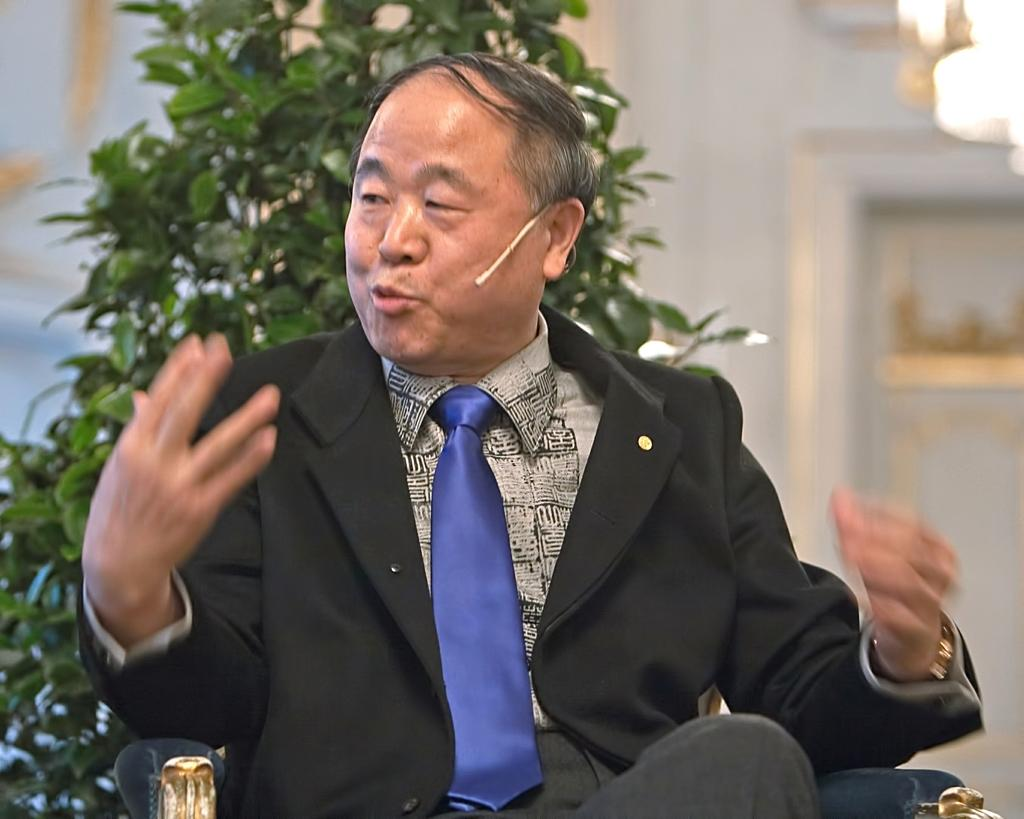Who or what is in the image? There is a person in the image. What is the person doing in the image? The person is sitting. What type of clothing is the person wearing? The person is wearing a blazer and a tie. What can be seen behind the person in the image? There is a plant behind the person. What type of waste can be seen in the image? There is no waste present in the image. How many cherries are on the person's tie in the image? There are no cherries on the person's tie in the image. 